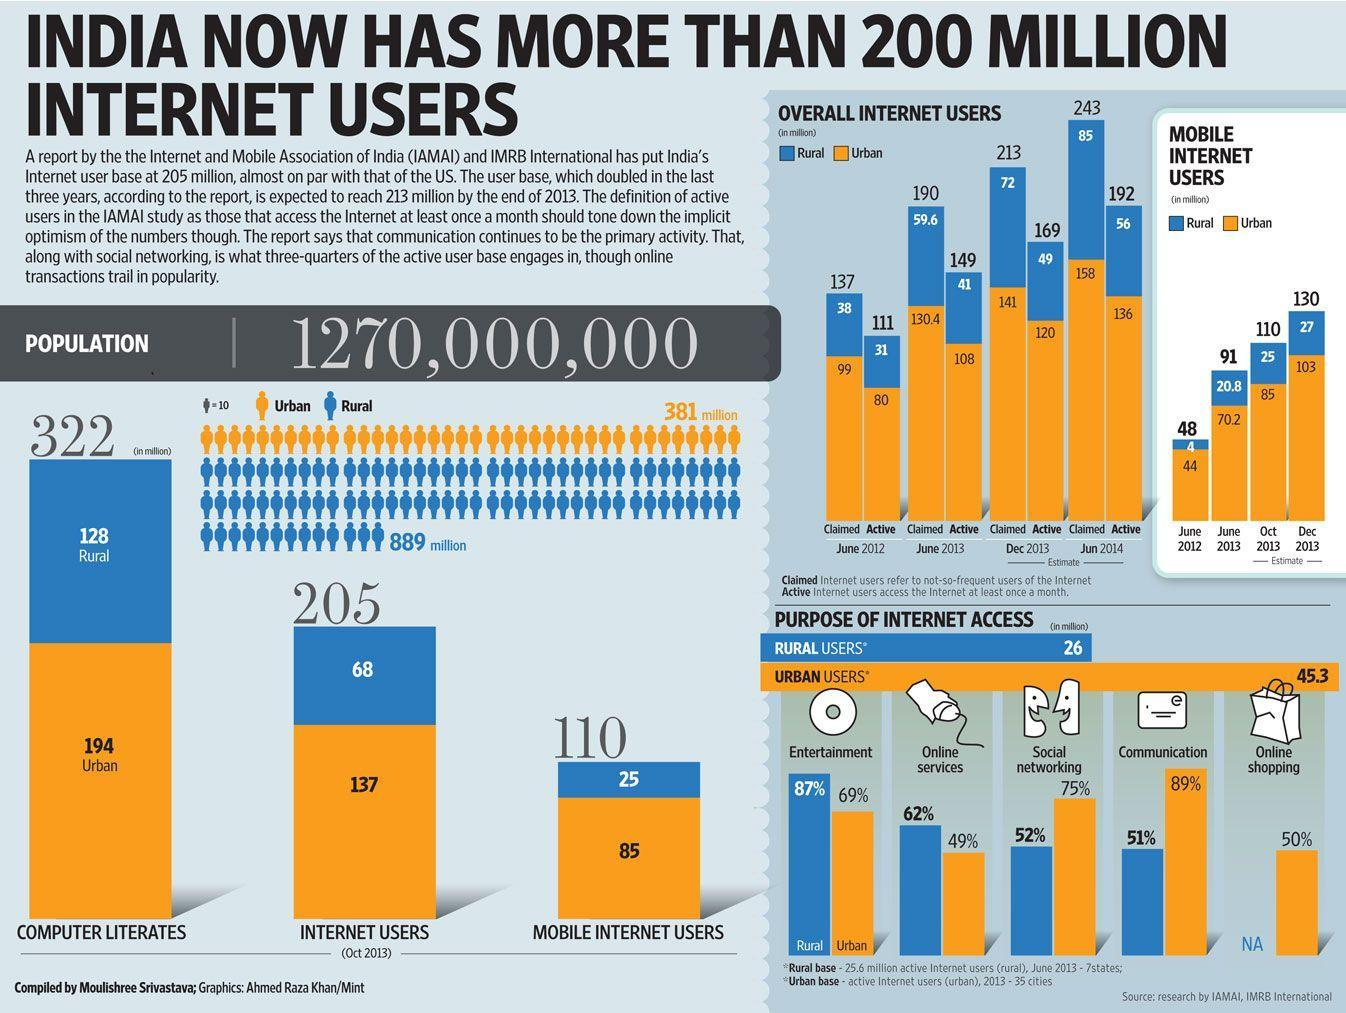What is the estimate of overall active internet users (in million) in urban areas of India in June 2014?
Answer the question with a short phrase. 136 How many mobile internet users (in millions) are there in rural areas of India as of Oct 2013? 25 What percentage of rural users in India have internet access for online services? 62% What is the estimate of mobile internet users (in million) in urban areas of India in December 2013? 103 What percentage of urban users in India do online shopping? 50% What percentage of urban users in India have internet access for communication purpose? 89% What is the estimate of overall active internet users (in million) in rural areas of India in June 2014? 56 What is the estimate of mobile internet users (in million) in rural areas of India in June 2013? 20.8 How many computer literates (in millions) are there in urban areas of India as of Oct 2013? 194 What is the number of internet users (in millions) in urban regions of India as of Oct 2013? 137 